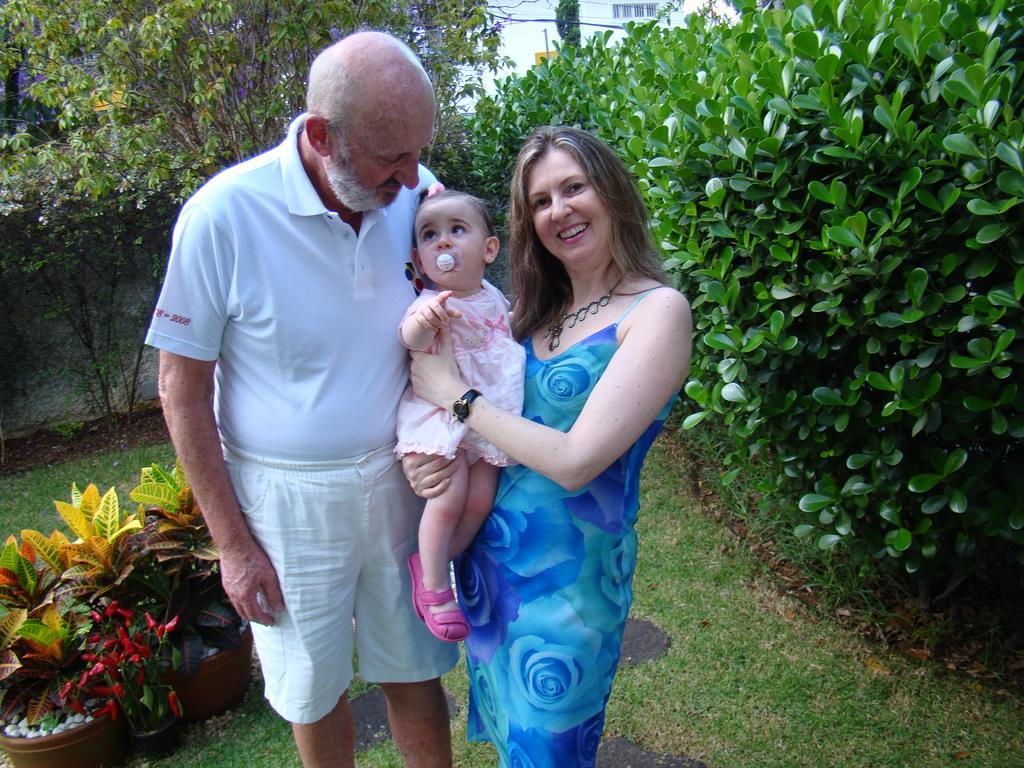In one or two sentences, can you explain what this image depicts? In this picture we can see there are two people are standing and the woman is holding a baby. Behind the women there are plants, trees and a wall. 